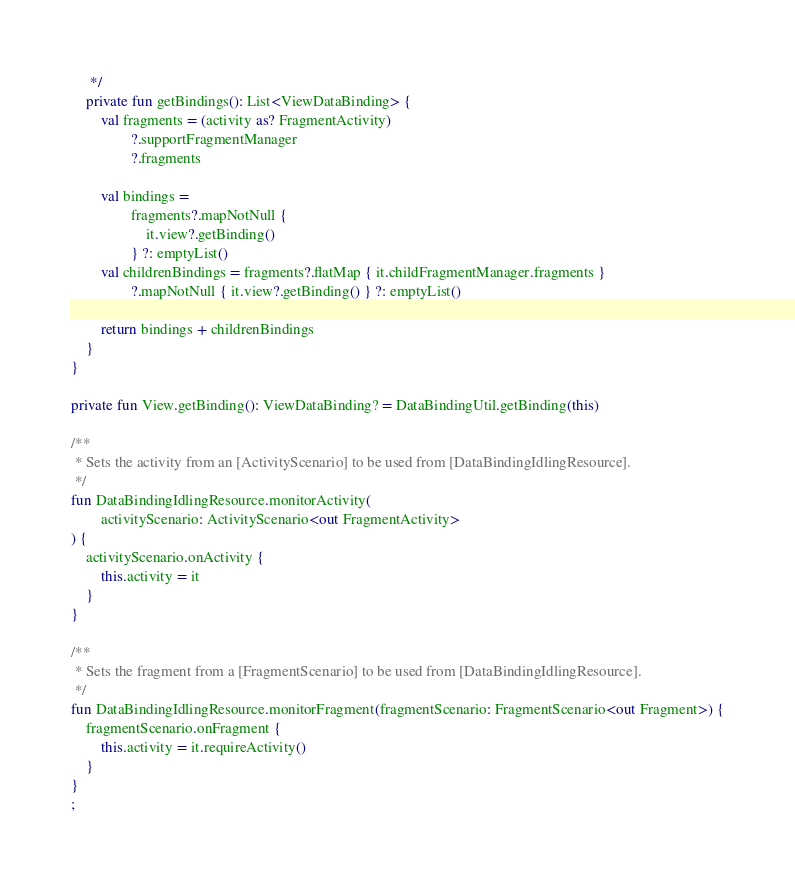Convert code to text. <code><loc_0><loc_0><loc_500><loc_500><_Kotlin_>     */
    private fun getBindings(): List<ViewDataBinding> {
        val fragments = (activity as? FragmentActivity)
                ?.supportFragmentManager
                ?.fragments

        val bindings =
                fragments?.mapNotNull {
                    it.view?.getBinding()
                } ?: emptyList()
        val childrenBindings = fragments?.flatMap { it.childFragmentManager.fragments }
                ?.mapNotNull { it.view?.getBinding() } ?: emptyList()

        return bindings + childrenBindings
    }
}

private fun View.getBinding(): ViewDataBinding? = DataBindingUtil.getBinding(this)

/**
 * Sets the activity from an [ActivityScenario] to be used from [DataBindingIdlingResource].
 */
fun DataBindingIdlingResource.monitorActivity(
        activityScenario: ActivityScenario<out FragmentActivity>
) {
    activityScenario.onActivity {
        this.activity = it
    }
}

/**
 * Sets the fragment from a [FragmentScenario] to be used from [DataBindingIdlingResource].
 */
fun DataBindingIdlingResource.monitorFragment(fragmentScenario: FragmentScenario<out Fragment>) {
    fragmentScenario.onFragment {
        this.activity = it.requireActivity()
    }
}
;</code> 